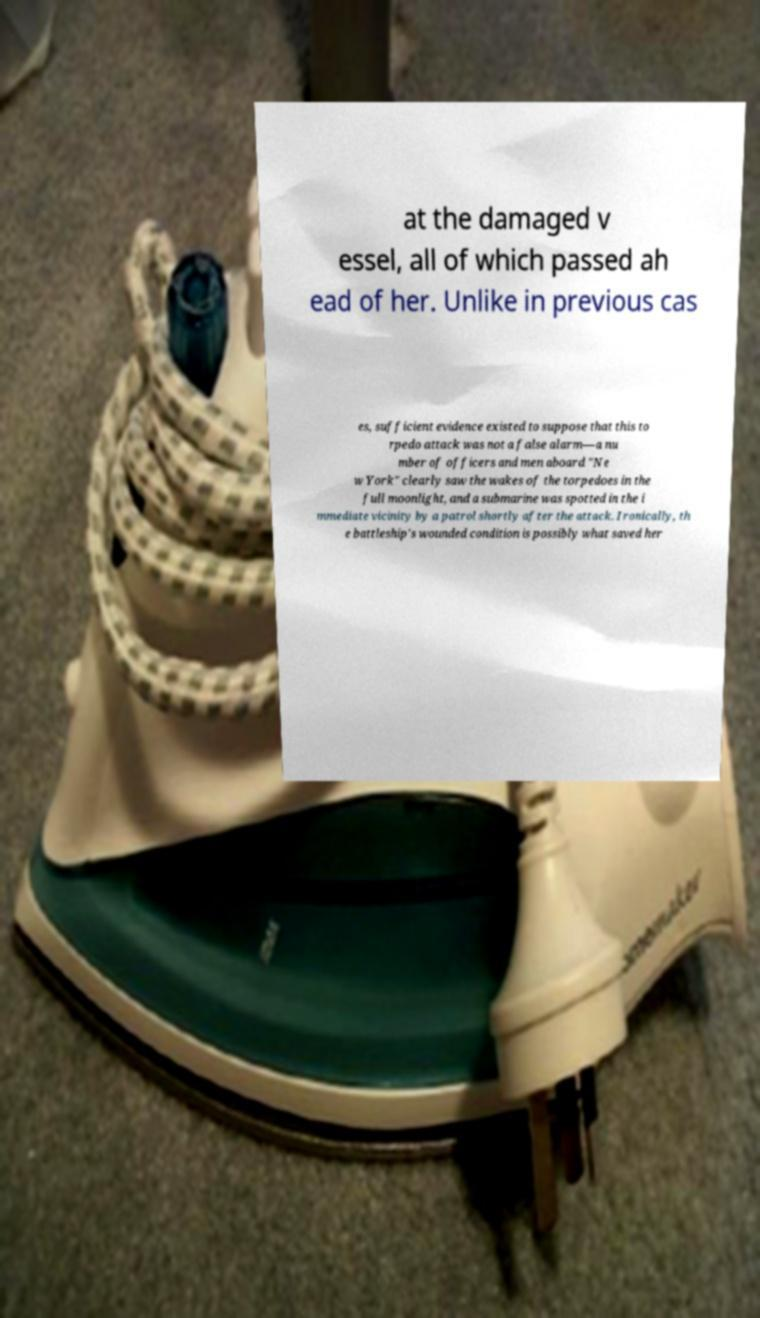There's text embedded in this image that I need extracted. Can you transcribe it verbatim? at the damaged v essel, all of which passed ah ead of her. Unlike in previous cas es, sufficient evidence existed to suppose that this to rpedo attack was not a false alarm—a nu mber of officers and men aboard "Ne w York" clearly saw the wakes of the torpedoes in the full moonlight, and a submarine was spotted in the i mmediate vicinity by a patrol shortly after the attack. Ironically, th e battleship's wounded condition is possibly what saved her 